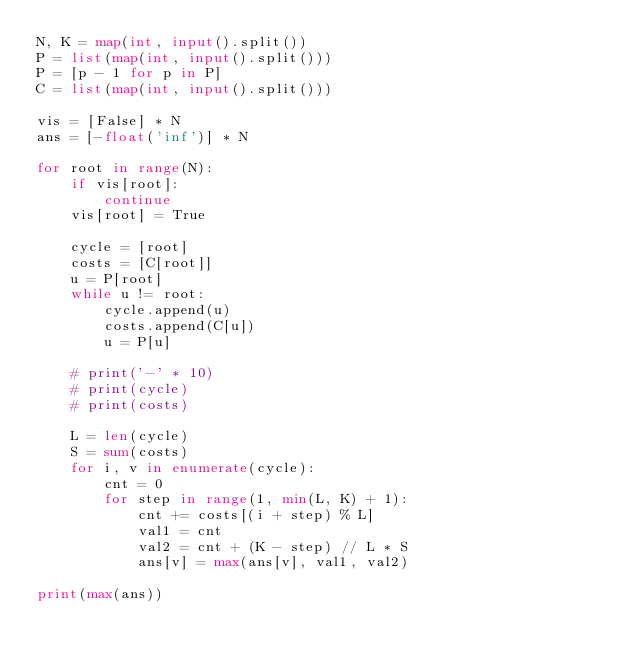<code> <loc_0><loc_0><loc_500><loc_500><_Python_>N, K = map(int, input().split())
P = list(map(int, input().split()))
P = [p - 1 for p in P]
C = list(map(int, input().split()))

vis = [False] * N
ans = [-float('inf')] * N

for root in range(N):
    if vis[root]:
        continue
    vis[root] = True

    cycle = [root]
    costs = [C[root]]
    u = P[root]
    while u != root:
        cycle.append(u)
        costs.append(C[u])
        u = P[u]

    # print('-' * 10)
    # print(cycle)
    # print(costs)

    L = len(cycle)
    S = sum(costs)
    for i, v in enumerate(cycle):
        cnt = 0
        for step in range(1, min(L, K) + 1):
            cnt += costs[(i + step) % L]
            val1 = cnt
            val2 = cnt + (K - step) // L * S
            ans[v] = max(ans[v], val1, val2)

print(max(ans))

</code> 